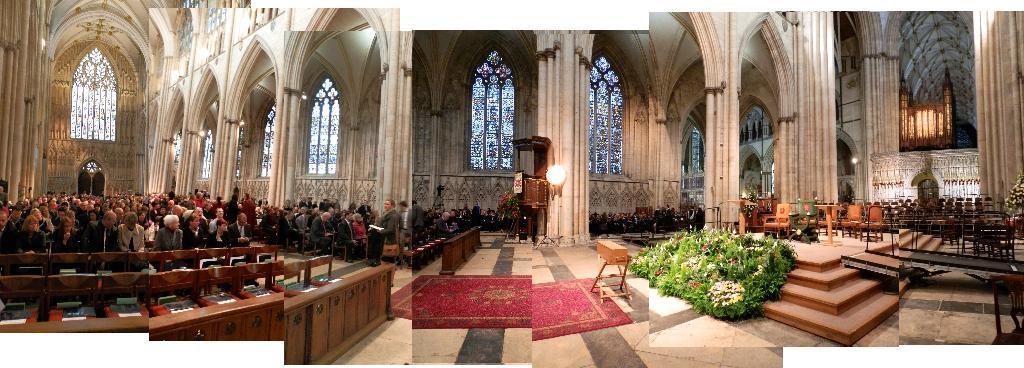Could you give a brief overview of what you see in this image? This is a collage image, in this image there are three pictures, in one picture there are people sitting on benches, around them there are walls, in another picture there are people sitting on benches and there is a wall, for that wall there is a glass window and there is a pillar, near the pillar there is a light and a cabinet and a mat on a floor, in another picture there are benches, plants and pillars. 